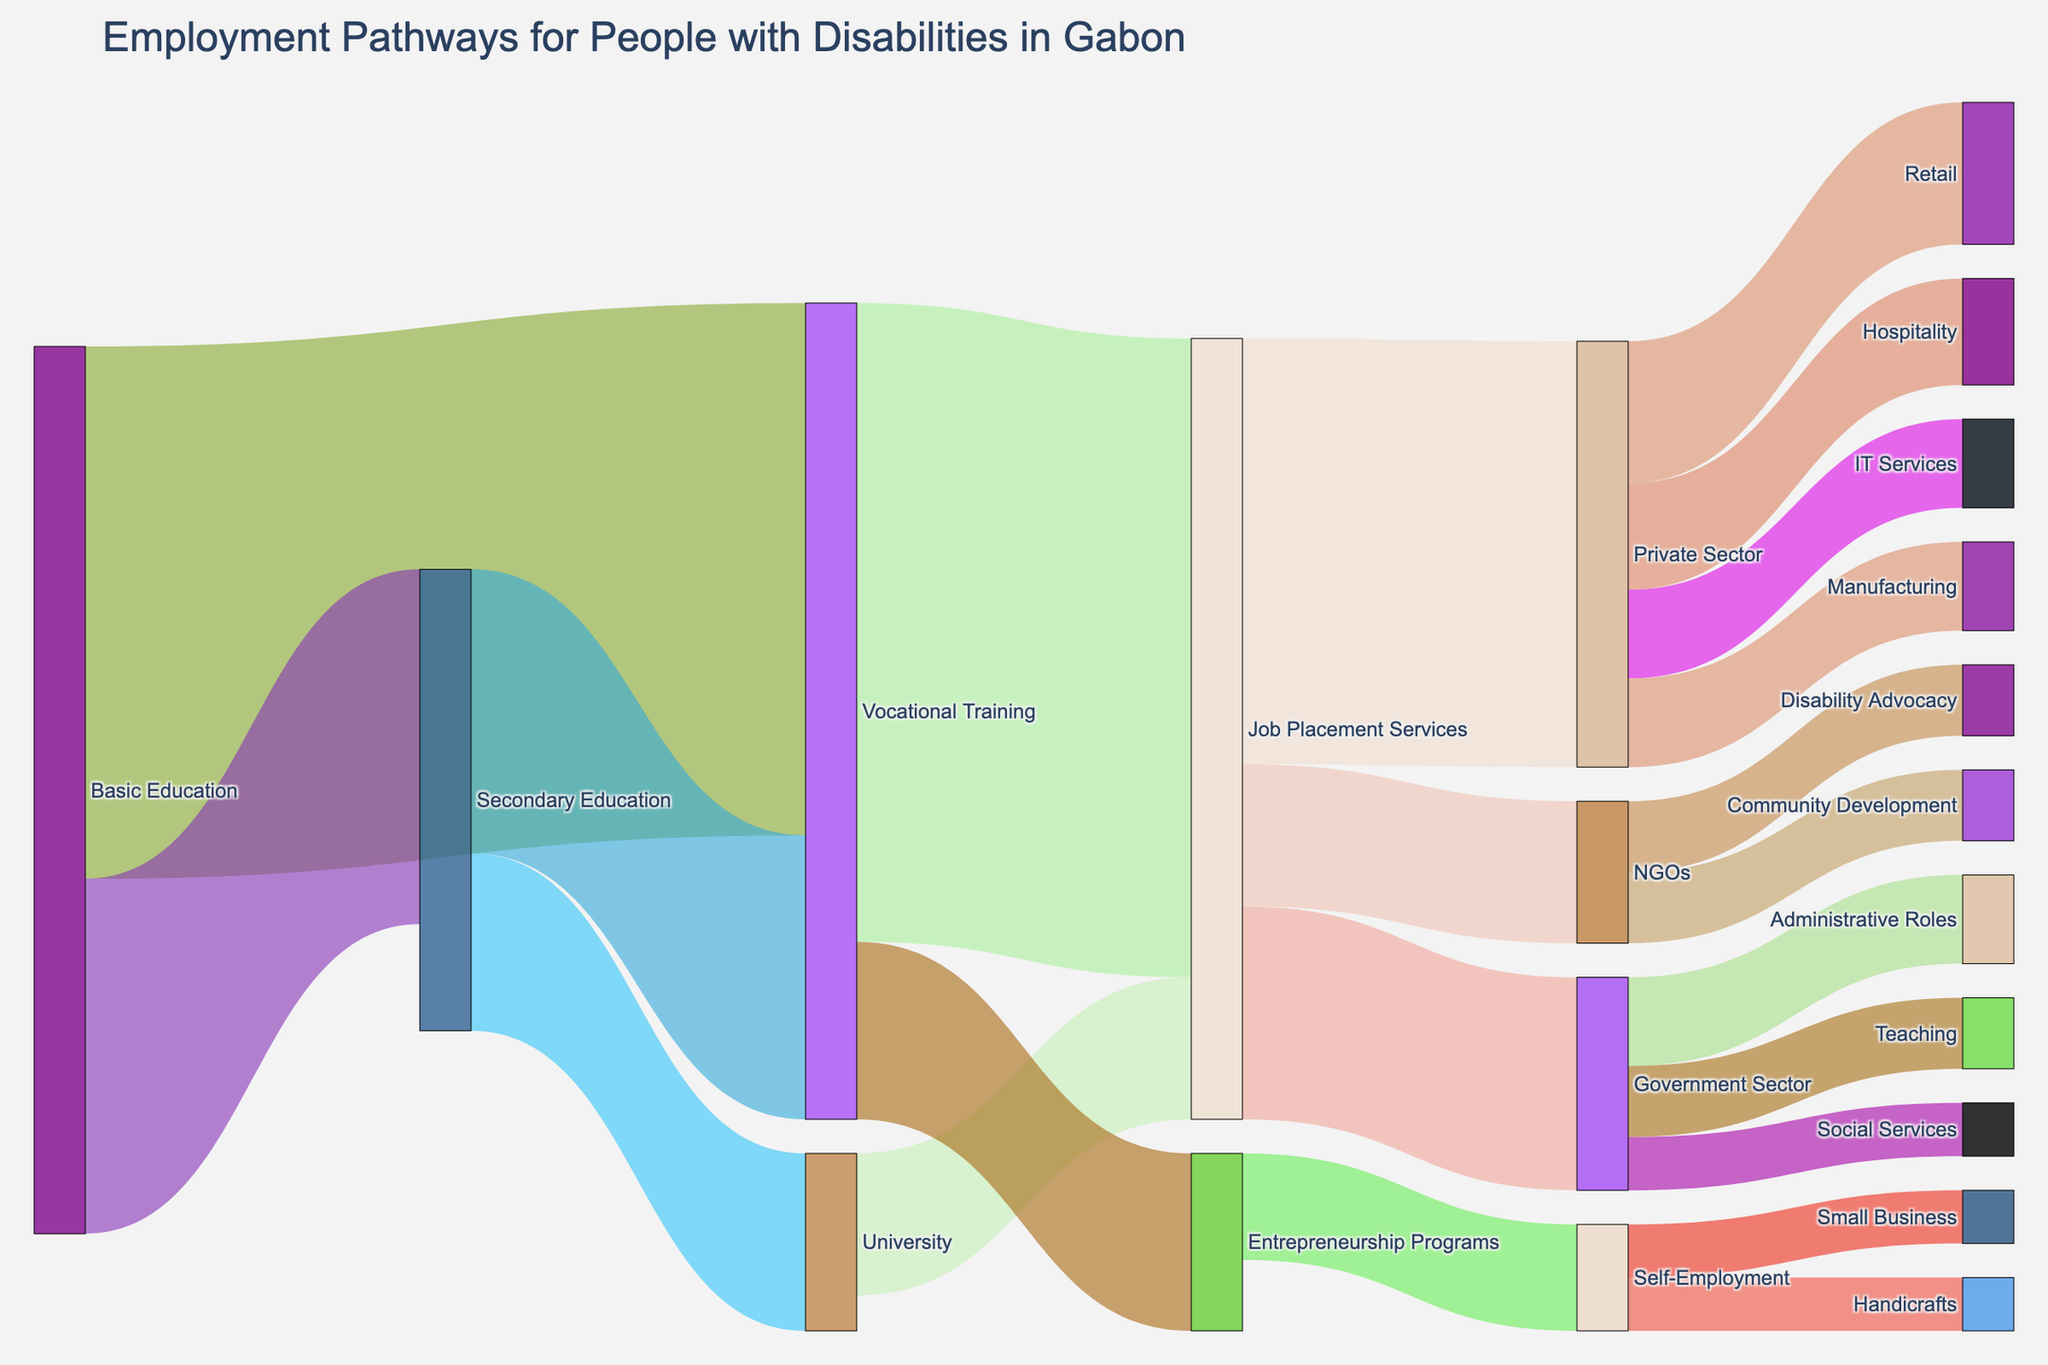What is the total number of people who moved from Basic Education to Vocational Training and Secondary Education? Add the number of people who moved from Basic Education to Vocational Training (150) and those who moved to Secondary Education (100). The total is 150 + 100 = 250.
Answer: 250 How many people proceeded from Secondary Education to University and Vocational Training combined? Add the number of people who moved from Secondary Education to University (50) and those who moved to Vocational Training (80). The total is 50 + 80 = 130.
Answer: 130 Which sector received the most individuals from Job Placement Services? Compare the number of individuals received by Government Sector (60), Private Sector (120), and NGOs (40) from Job Placement Services. The Private Sector received the most individuals.
Answer: Private Sector Compare the number of individuals who went to Government Sector from Job Placement Services versus those who went to NGOs. The number of individuals who went to Government Sector is 60, and the number who went to NGOs is 40. Since 60 > 40, more individuals went to the Government Sector.
Answer: Government Sector How many people went into Self-Employment through Entrepreneurship Programs? Look at the value for the link between Entrepreneurship Programs and Self-Employment, which is 30.
Answer: 30 What is the difference between the number of individuals in Retail and Hospitality from the Private Sector? From the Private Sector, 40 individuals went into Retail and 30 into Hospitality. The difference is 40 - 30 = 10.
Answer: 10 How many more people went into IT Services compared to Manufacturing in the Private Sector? In the Private Sector, 25 individuals went into IT Services and another 25 into Manufacturing. The difference is 25 - 25 = 0.
Answer: 0 Which program or sector did the most people enter directly from Vocational Training? Compare the numbers: Entrepreneurship Programs (50) and Job Placement Services (180). Most people entered Job Placement Services.
Answer: Job Placement Services How many individuals moved from Job Placement Services into the Government Sector and NGOs combined? Add the number of individuals who moved into the Government Sector (60) and NGOs (40) from Job Placement Services, resulting in 60 + 40 = 100.
Answer: 100 Based on the diagram, which career paths in the Government Sector have the least number of individuals? Compare Administrative Roles (25), Teaching (20), and Social Services (15). Social Services has the least number of individuals.
Answer: Social Services 